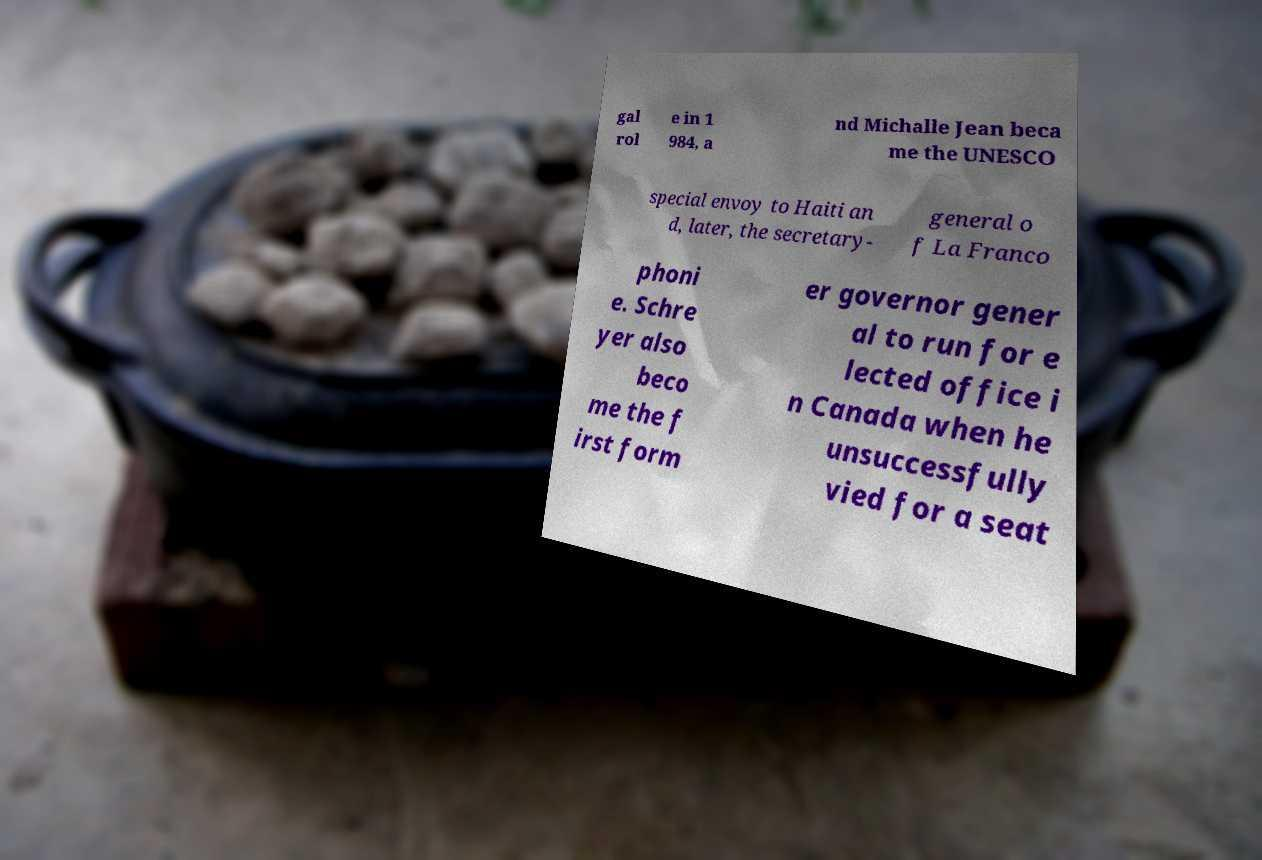I need the written content from this picture converted into text. Can you do that? gal rol e in 1 984, a nd Michalle Jean beca me the UNESCO special envoy to Haiti an d, later, the secretary- general o f La Franco phoni e. Schre yer also beco me the f irst form er governor gener al to run for e lected office i n Canada when he unsuccessfully vied for a seat 